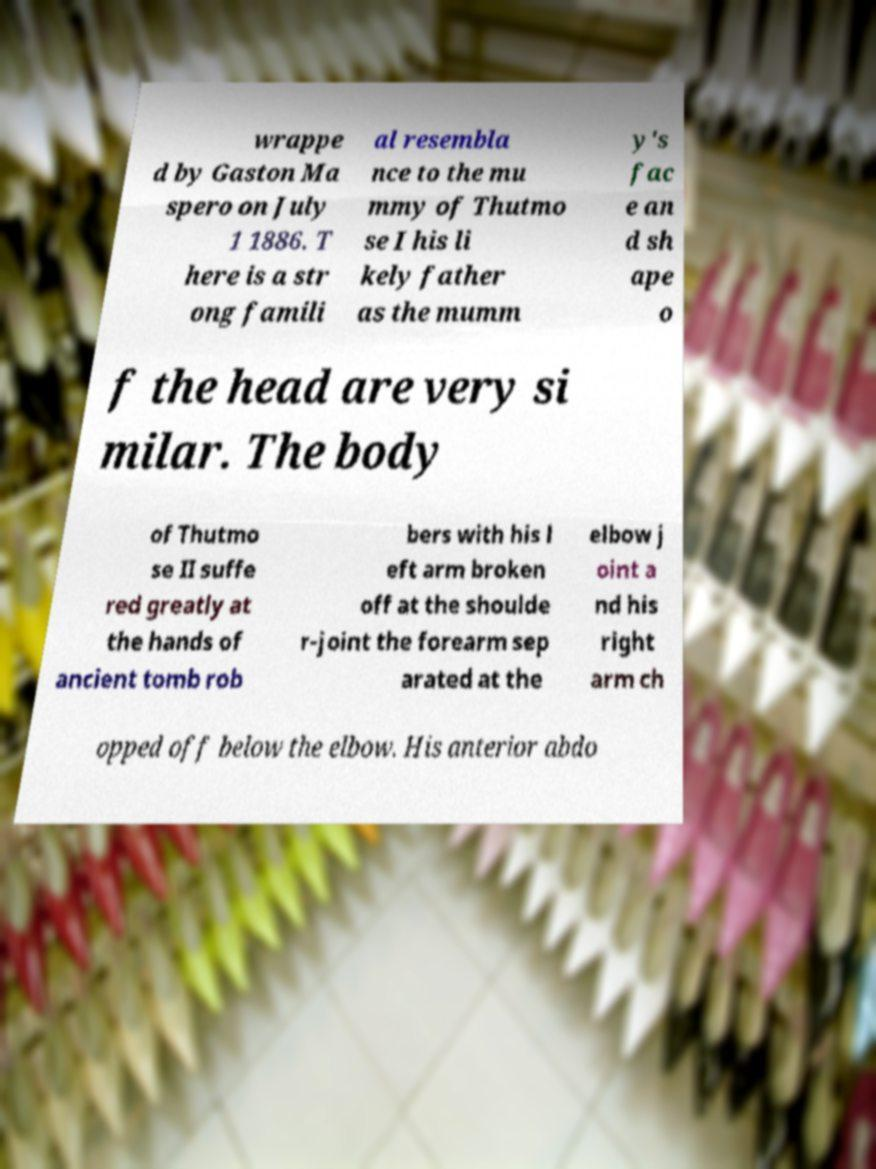Please identify and transcribe the text found in this image. wrappe d by Gaston Ma spero on July 1 1886. T here is a str ong famili al resembla nce to the mu mmy of Thutmo se I his li kely father as the mumm y's fac e an d sh ape o f the head are very si milar. The body of Thutmo se II suffe red greatly at the hands of ancient tomb rob bers with his l eft arm broken off at the shoulde r-joint the forearm sep arated at the elbow j oint a nd his right arm ch opped off below the elbow. His anterior abdo 